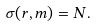<formula> <loc_0><loc_0><loc_500><loc_500>\sigma ( r , m ) = N .</formula> 